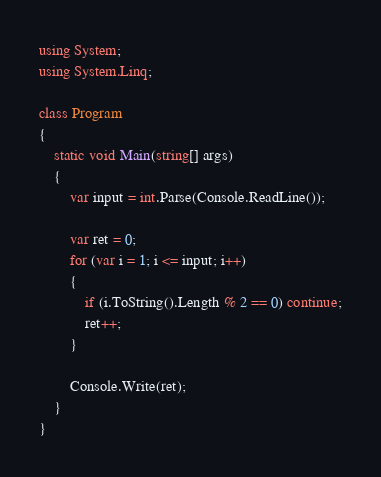<code> <loc_0><loc_0><loc_500><loc_500><_C#_>using System;
using System.Linq;

class Program
{
    static void Main(string[] args)
    {
        var input = int.Parse(Console.ReadLine());

        var ret = 0;
        for (var i = 1; i <= input; i++)
        {
            if (i.ToString().Length % 2 == 0) continue;
            ret++;
        }

        Console.Write(ret);
    }
}

</code> 